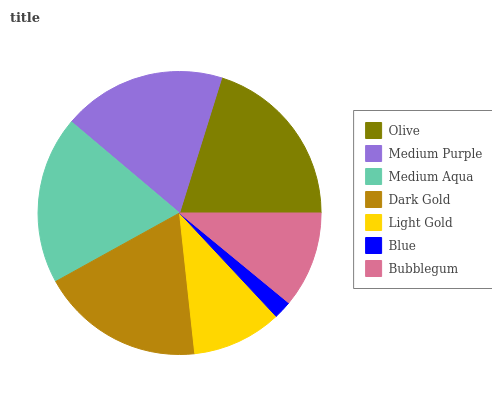Is Blue the minimum?
Answer yes or no. Yes. Is Olive the maximum?
Answer yes or no. Yes. Is Medium Purple the minimum?
Answer yes or no. No. Is Medium Purple the maximum?
Answer yes or no. No. Is Olive greater than Medium Purple?
Answer yes or no. Yes. Is Medium Purple less than Olive?
Answer yes or no. Yes. Is Medium Purple greater than Olive?
Answer yes or no. No. Is Olive less than Medium Purple?
Answer yes or no. No. Is Medium Purple the high median?
Answer yes or no. Yes. Is Medium Purple the low median?
Answer yes or no. Yes. Is Blue the high median?
Answer yes or no. No. Is Dark Gold the low median?
Answer yes or no. No. 